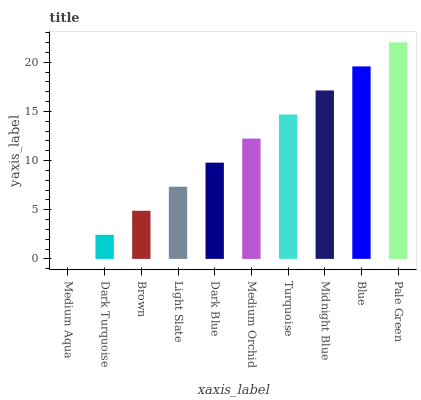Is Medium Aqua the minimum?
Answer yes or no. Yes. Is Pale Green the maximum?
Answer yes or no. Yes. Is Dark Turquoise the minimum?
Answer yes or no. No. Is Dark Turquoise the maximum?
Answer yes or no. No. Is Dark Turquoise greater than Medium Aqua?
Answer yes or no. Yes. Is Medium Aqua less than Dark Turquoise?
Answer yes or no. Yes. Is Medium Aqua greater than Dark Turquoise?
Answer yes or no. No. Is Dark Turquoise less than Medium Aqua?
Answer yes or no. No. Is Medium Orchid the high median?
Answer yes or no. Yes. Is Dark Blue the low median?
Answer yes or no. Yes. Is Medium Aqua the high median?
Answer yes or no. No. Is Light Slate the low median?
Answer yes or no. No. 